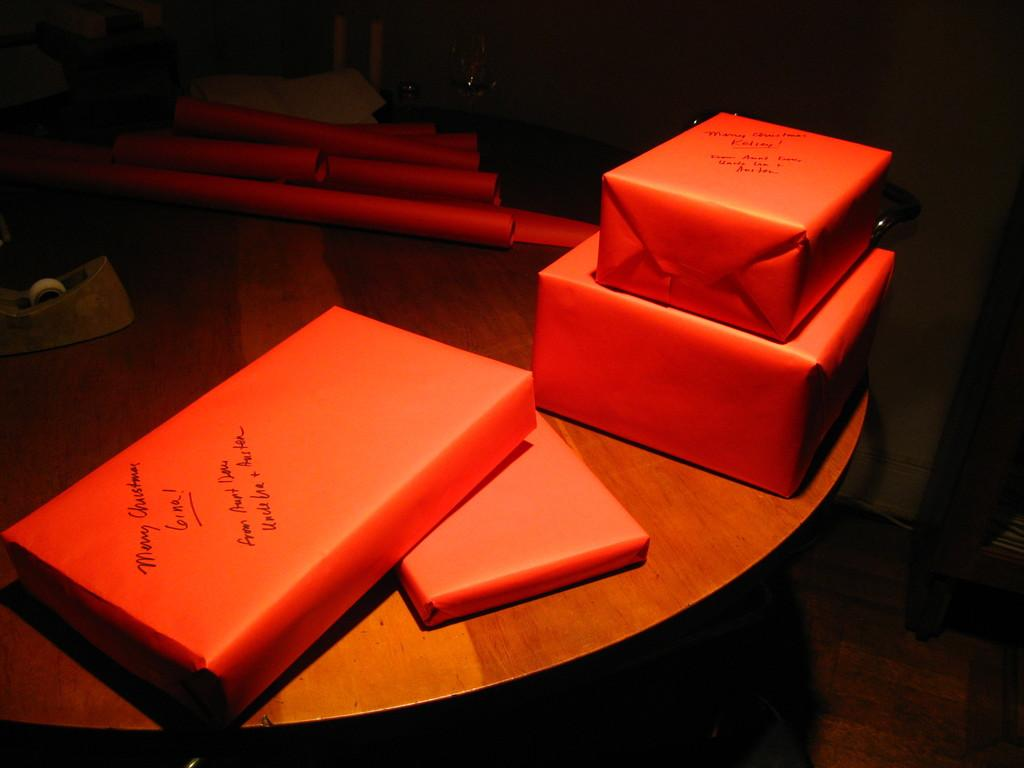<image>
Summarize the visual content of the image. On top of this round wooden table are a number of presents wrapped with orange paper including one that says Merry Christmas. 